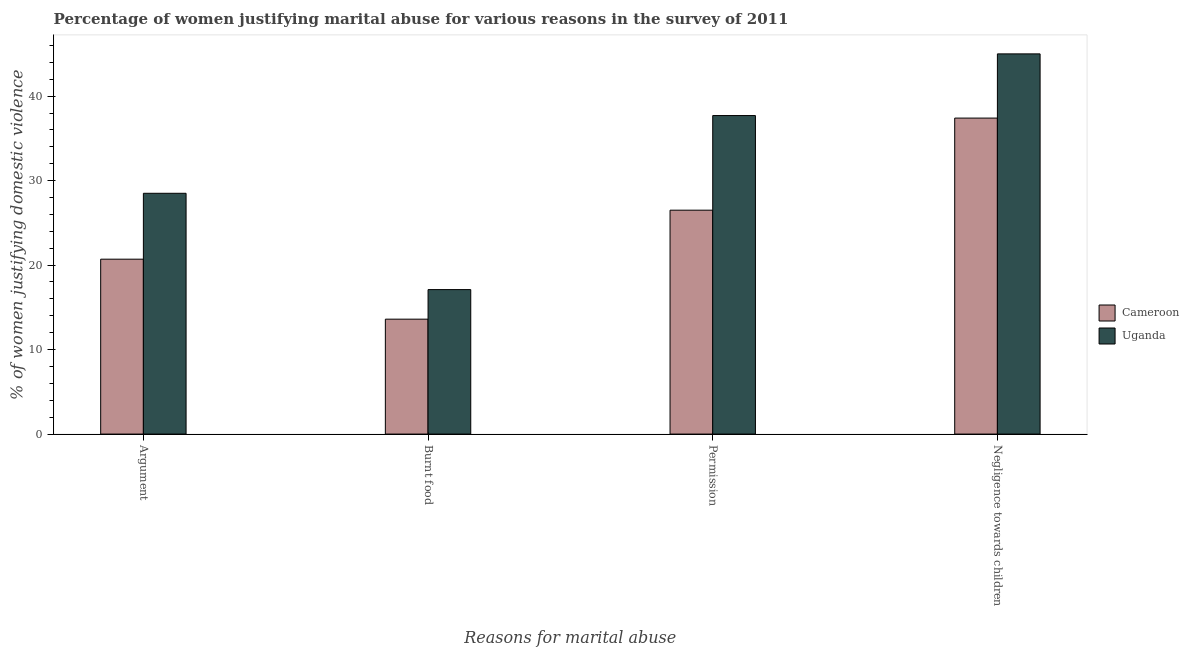How many different coloured bars are there?
Provide a succinct answer. 2. How many groups of bars are there?
Keep it short and to the point. 4. How many bars are there on the 2nd tick from the left?
Provide a short and direct response. 2. How many bars are there on the 2nd tick from the right?
Ensure brevity in your answer.  2. What is the label of the 4th group of bars from the left?
Your response must be concise. Negligence towards children. What is the percentage of women justifying abuse for going without permission in Uganda?
Provide a succinct answer. 37.7. Across all countries, what is the maximum percentage of women justifying abuse for going without permission?
Make the answer very short. 37.7. In which country was the percentage of women justifying abuse for going without permission maximum?
Make the answer very short. Uganda. In which country was the percentage of women justifying abuse for going without permission minimum?
Give a very brief answer. Cameroon. What is the total percentage of women justifying abuse for showing negligence towards children in the graph?
Provide a succinct answer. 82.4. What is the difference between the percentage of women justifying abuse for burning food in Uganda and that in Cameroon?
Keep it short and to the point. 3.5. What is the difference between the percentage of women justifying abuse for showing negligence towards children in Uganda and the percentage of women justifying abuse for burning food in Cameroon?
Ensure brevity in your answer.  31.4. What is the average percentage of women justifying abuse for showing negligence towards children per country?
Ensure brevity in your answer.  41.2. What is the difference between the percentage of women justifying abuse in the case of an argument and percentage of women justifying abuse for showing negligence towards children in Uganda?
Your answer should be very brief. -16.5. What is the ratio of the percentage of women justifying abuse in the case of an argument in Uganda to that in Cameroon?
Provide a succinct answer. 1.38. Is the percentage of women justifying abuse for going without permission in Uganda less than that in Cameroon?
Offer a terse response. No. Is the difference between the percentage of women justifying abuse for going without permission in Cameroon and Uganda greater than the difference between the percentage of women justifying abuse for showing negligence towards children in Cameroon and Uganda?
Your response must be concise. No. What is the difference between the highest and the second highest percentage of women justifying abuse for showing negligence towards children?
Give a very brief answer. 7.6. What is the difference between the highest and the lowest percentage of women justifying abuse in the case of an argument?
Provide a succinct answer. 7.8. What does the 1st bar from the left in Negligence towards children represents?
Your answer should be very brief. Cameroon. What does the 1st bar from the right in Permission represents?
Your answer should be very brief. Uganda. How many bars are there?
Your answer should be compact. 8. How many countries are there in the graph?
Ensure brevity in your answer.  2. Are the values on the major ticks of Y-axis written in scientific E-notation?
Provide a short and direct response. No. Does the graph contain grids?
Keep it short and to the point. No. What is the title of the graph?
Your answer should be very brief. Percentage of women justifying marital abuse for various reasons in the survey of 2011. Does "High income" appear as one of the legend labels in the graph?
Your answer should be very brief. No. What is the label or title of the X-axis?
Your answer should be compact. Reasons for marital abuse. What is the label or title of the Y-axis?
Provide a short and direct response. % of women justifying domestic violence. What is the % of women justifying domestic violence in Cameroon in Argument?
Ensure brevity in your answer.  20.7. What is the % of women justifying domestic violence in Uganda in Argument?
Offer a very short reply. 28.5. What is the % of women justifying domestic violence of Uganda in Burnt food?
Provide a succinct answer. 17.1. What is the % of women justifying domestic violence of Uganda in Permission?
Provide a succinct answer. 37.7. What is the % of women justifying domestic violence of Cameroon in Negligence towards children?
Offer a very short reply. 37.4. Across all Reasons for marital abuse, what is the maximum % of women justifying domestic violence in Cameroon?
Ensure brevity in your answer.  37.4. What is the total % of women justifying domestic violence in Cameroon in the graph?
Give a very brief answer. 98.2. What is the total % of women justifying domestic violence in Uganda in the graph?
Ensure brevity in your answer.  128.3. What is the difference between the % of women justifying domestic violence in Cameroon in Argument and that in Burnt food?
Ensure brevity in your answer.  7.1. What is the difference between the % of women justifying domestic violence in Uganda in Argument and that in Burnt food?
Ensure brevity in your answer.  11.4. What is the difference between the % of women justifying domestic violence of Cameroon in Argument and that in Permission?
Give a very brief answer. -5.8. What is the difference between the % of women justifying domestic violence in Uganda in Argument and that in Permission?
Give a very brief answer. -9.2. What is the difference between the % of women justifying domestic violence in Cameroon in Argument and that in Negligence towards children?
Offer a very short reply. -16.7. What is the difference between the % of women justifying domestic violence in Uganda in Argument and that in Negligence towards children?
Give a very brief answer. -16.5. What is the difference between the % of women justifying domestic violence in Cameroon in Burnt food and that in Permission?
Give a very brief answer. -12.9. What is the difference between the % of women justifying domestic violence in Uganda in Burnt food and that in Permission?
Provide a succinct answer. -20.6. What is the difference between the % of women justifying domestic violence in Cameroon in Burnt food and that in Negligence towards children?
Your response must be concise. -23.8. What is the difference between the % of women justifying domestic violence of Uganda in Burnt food and that in Negligence towards children?
Your answer should be very brief. -27.9. What is the difference between the % of women justifying domestic violence of Uganda in Permission and that in Negligence towards children?
Your answer should be compact. -7.3. What is the difference between the % of women justifying domestic violence of Cameroon in Argument and the % of women justifying domestic violence of Uganda in Burnt food?
Give a very brief answer. 3.6. What is the difference between the % of women justifying domestic violence in Cameroon in Argument and the % of women justifying domestic violence in Uganda in Negligence towards children?
Give a very brief answer. -24.3. What is the difference between the % of women justifying domestic violence of Cameroon in Burnt food and the % of women justifying domestic violence of Uganda in Permission?
Ensure brevity in your answer.  -24.1. What is the difference between the % of women justifying domestic violence of Cameroon in Burnt food and the % of women justifying domestic violence of Uganda in Negligence towards children?
Offer a terse response. -31.4. What is the difference between the % of women justifying domestic violence of Cameroon in Permission and the % of women justifying domestic violence of Uganda in Negligence towards children?
Ensure brevity in your answer.  -18.5. What is the average % of women justifying domestic violence of Cameroon per Reasons for marital abuse?
Keep it short and to the point. 24.55. What is the average % of women justifying domestic violence of Uganda per Reasons for marital abuse?
Keep it short and to the point. 32.08. What is the difference between the % of women justifying domestic violence of Cameroon and % of women justifying domestic violence of Uganda in Argument?
Provide a succinct answer. -7.8. What is the difference between the % of women justifying domestic violence in Cameroon and % of women justifying domestic violence in Uganda in Permission?
Keep it short and to the point. -11.2. What is the difference between the % of women justifying domestic violence of Cameroon and % of women justifying domestic violence of Uganda in Negligence towards children?
Give a very brief answer. -7.6. What is the ratio of the % of women justifying domestic violence of Cameroon in Argument to that in Burnt food?
Offer a very short reply. 1.52. What is the ratio of the % of women justifying domestic violence of Uganda in Argument to that in Burnt food?
Your answer should be compact. 1.67. What is the ratio of the % of women justifying domestic violence of Cameroon in Argument to that in Permission?
Provide a succinct answer. 0.78. What is the ratio of the % of women justifying domestic violence in Uganda in Argument to that in Permission?
Offer a terse response. 0.76. What is the ratio of the % of women justifying domestic violence of Cameroon in Argument to that in Negligence towards children?
Offer a very short reply. 0.55. What is the ratio of the % of women justifying domestic violence of Uganda in Argument to that in Negligence towards children?
Keep it short and to the point. 0.63. What is the ratio of the % of women justifying domestic violence in Cameroon in Burnt food to that in Permission?
Your answer should be very brief. 0.51. What is the ratio of the % of women justifying domestic violence in Uganda in Burnt food to that in Permission?
Provide a succinct answer. 0.45. What is the ratio of the % of women justifying domestic violence of Cameroon in Burnt food to that in Negligence towards children?
Give a very brief answer. 0.36. What is the ratio of the % of women justifying domestic violence in Uganda in Burnt food to that in Negligence towards children?
Offer a very short reply. 0.38. What is the ratio of the % of women justifying domestic violence of Cameroon in Permission to that in Negligence towards children?
Your answer should be compact. 0.71. What is the ratio of the % of women justifying domestic violence in Uganda in Permission to that in Negligence towards children?
Make the answer very short. 0.84. What is the difference between the highest and the lowest % of women justifying domestic violence of Cameroon?
Your answer should be compact. 23.8. What is the difference between the highest and the lowest % of women justifying domestic violence of Uganda?
Provide a succinct answer. 27.9. 